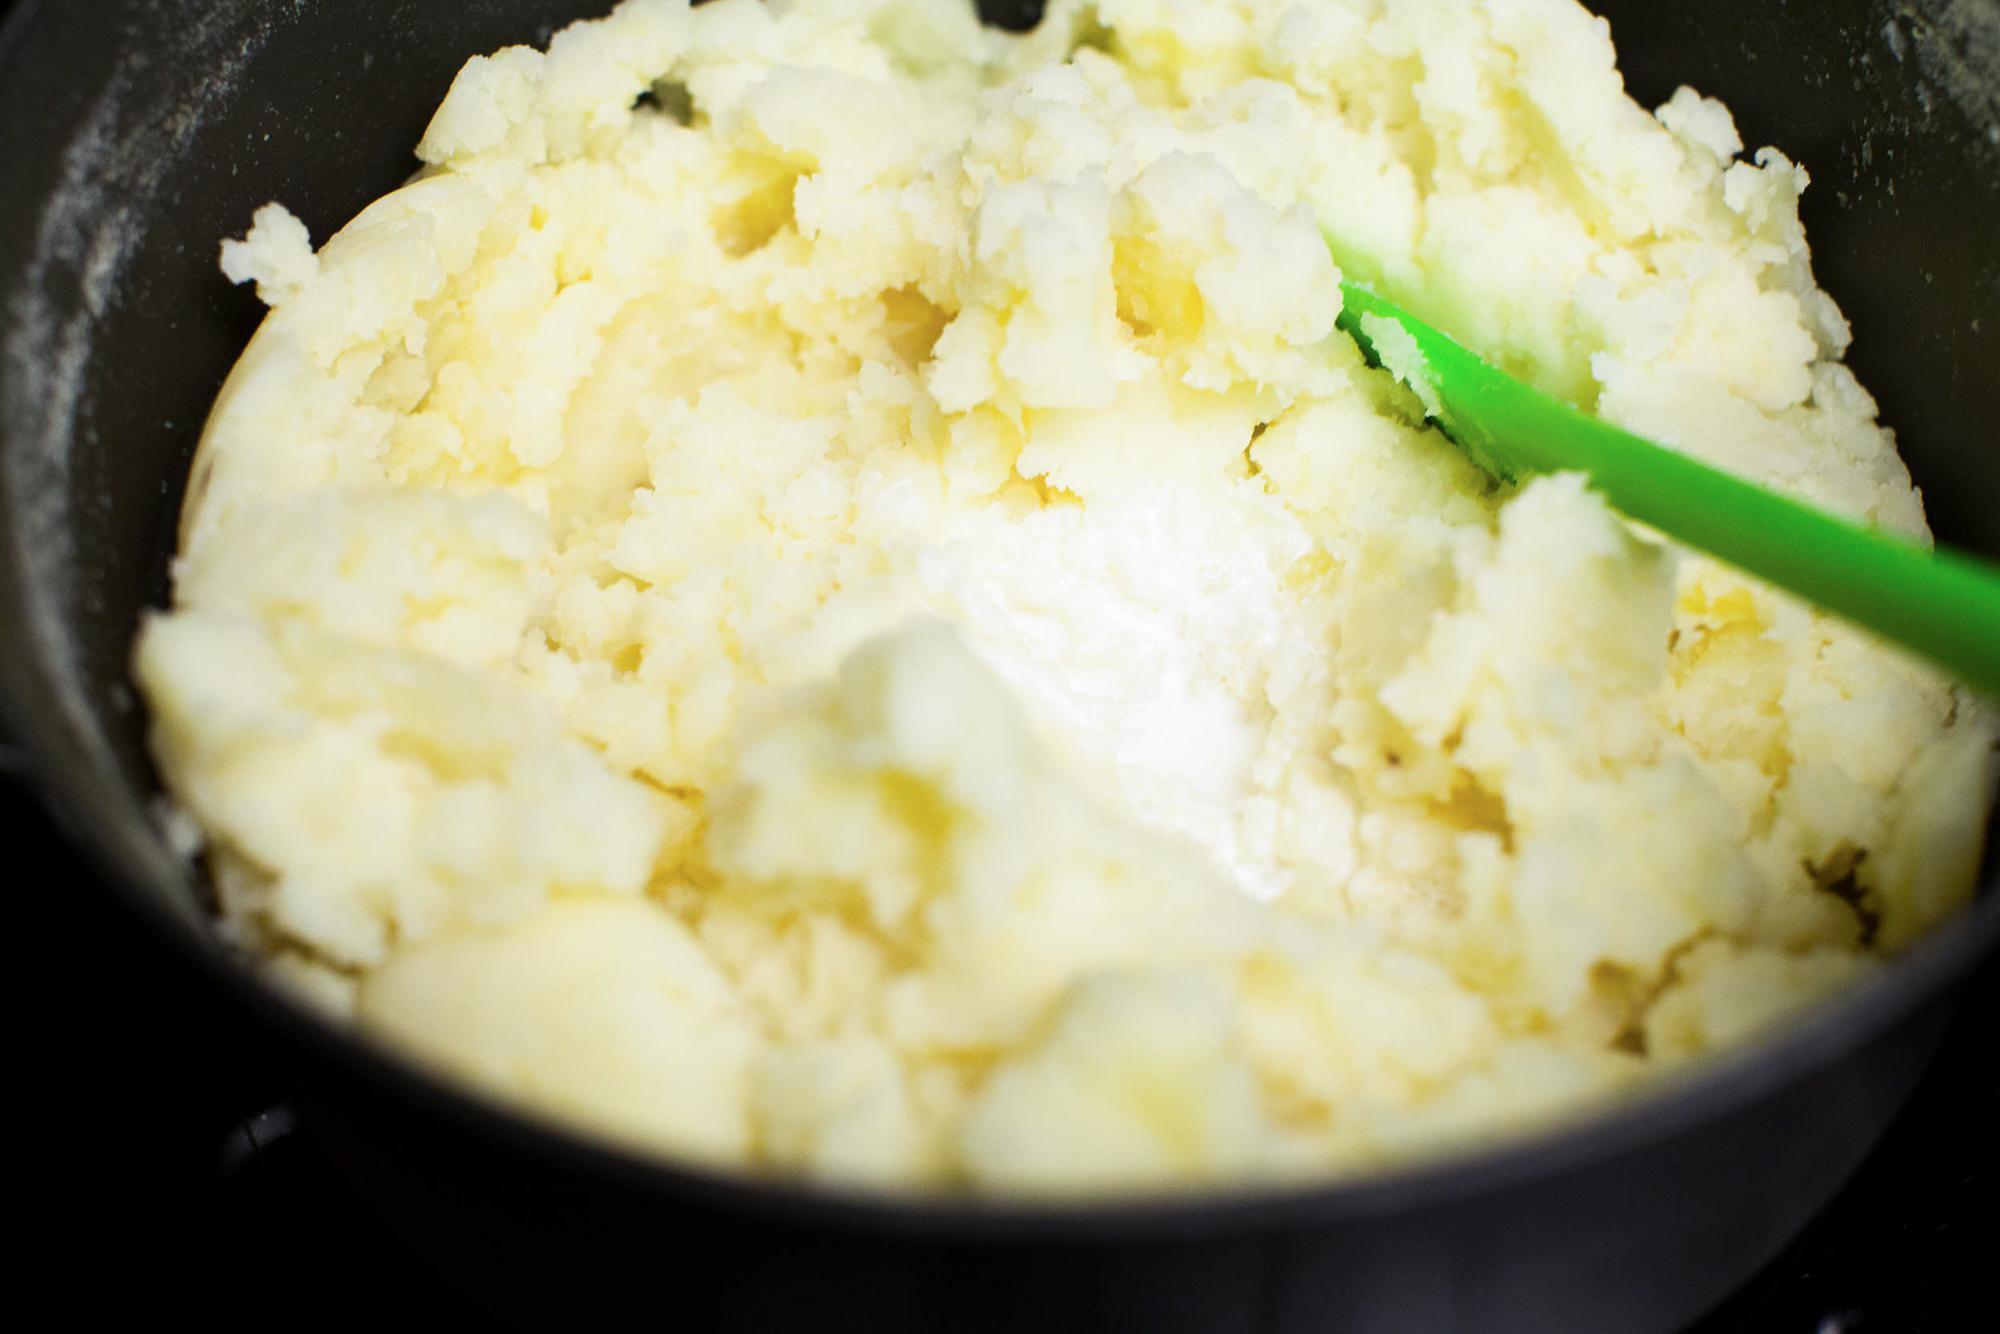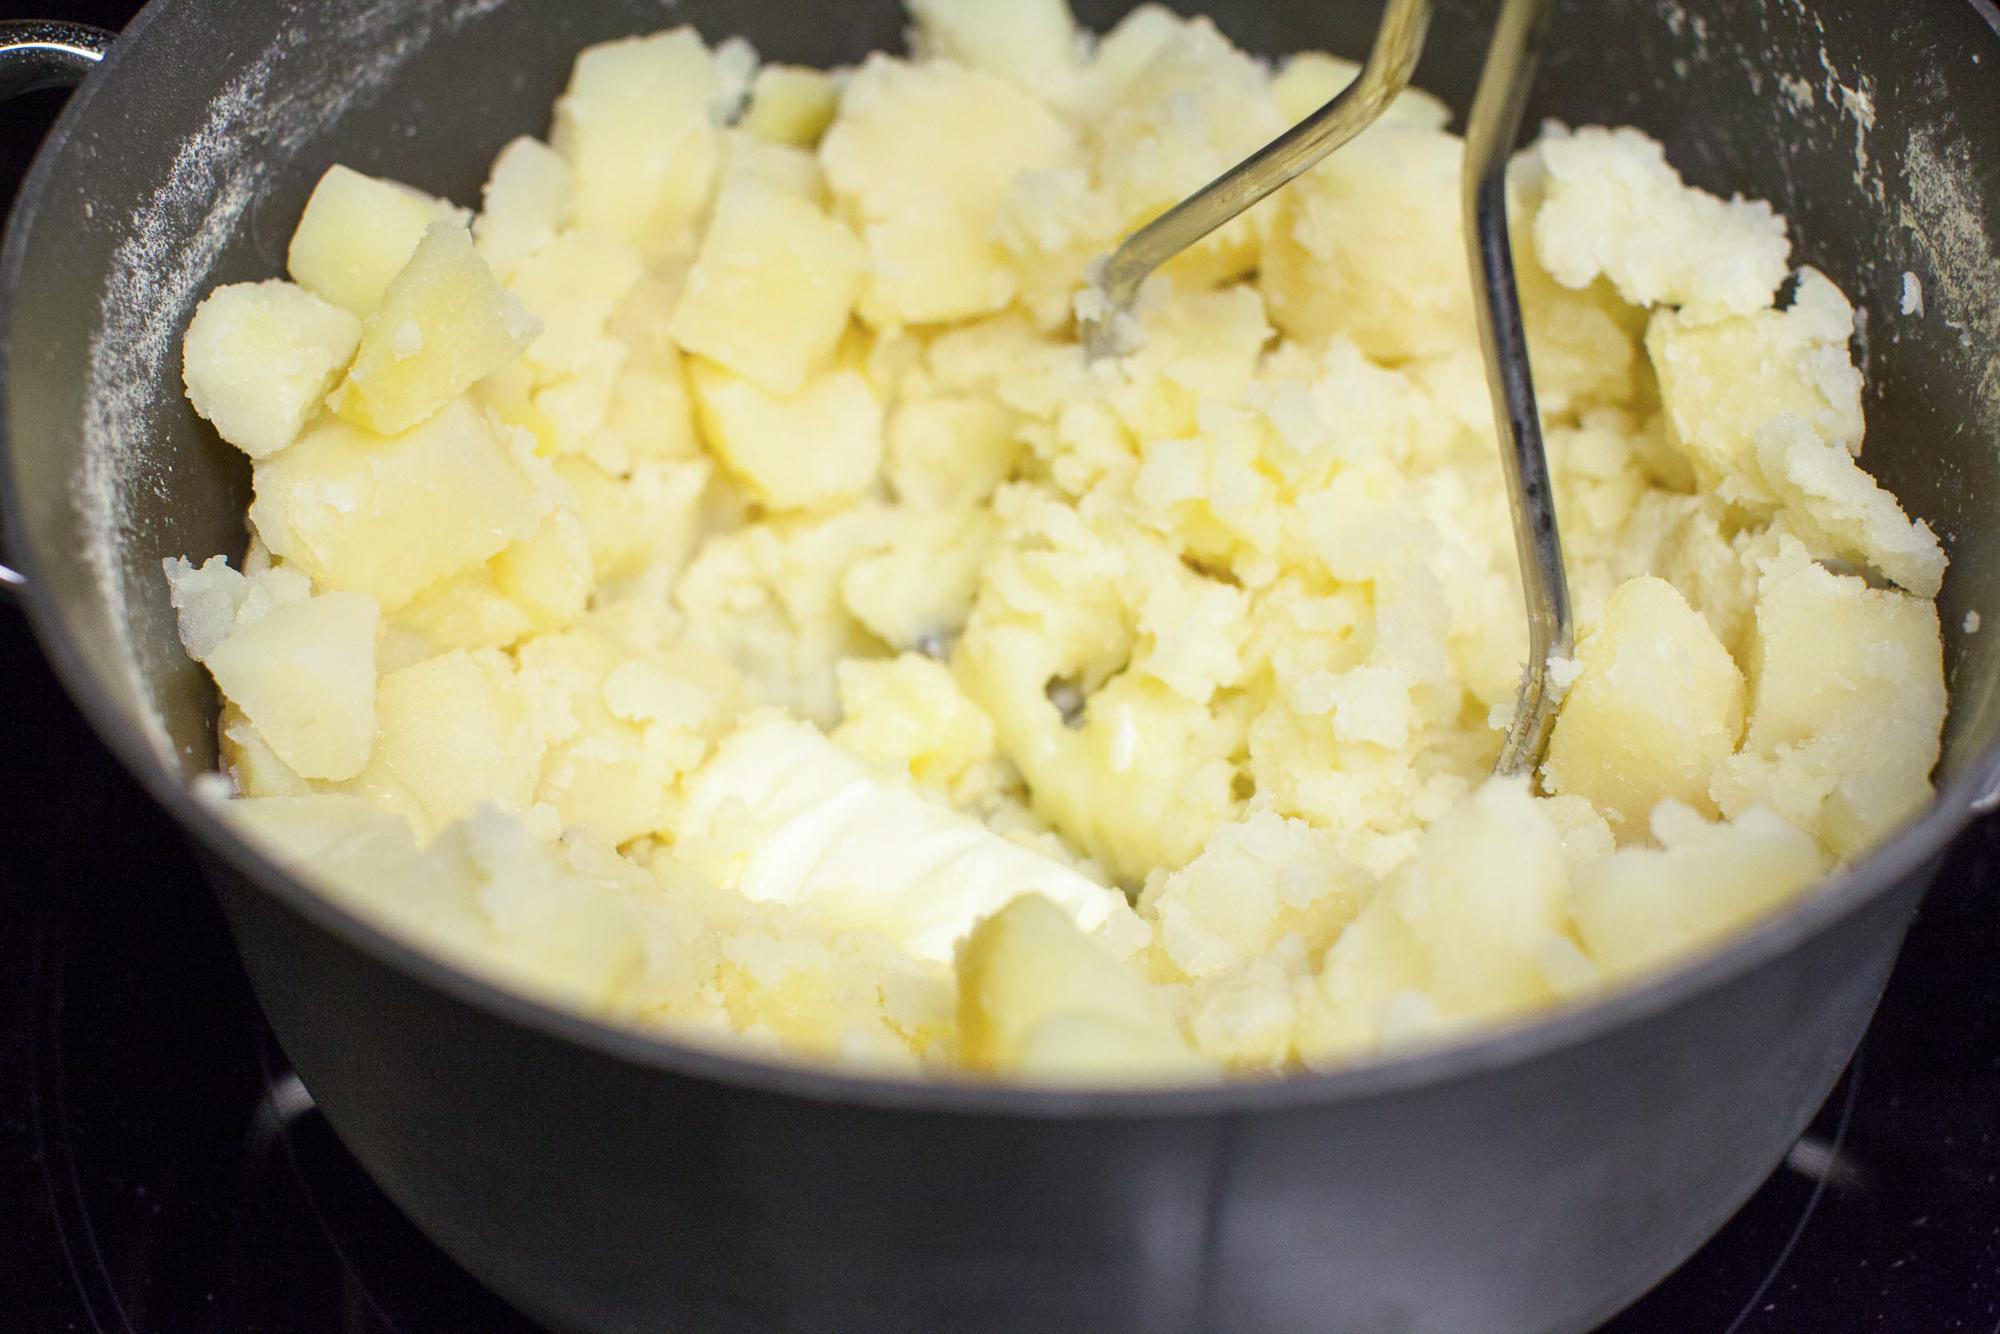The first image is the image on the left, the second image is the image on the right. Given the left and right images, does the statement "One image shows potatoes in a pot of water before boiling." hold true? Answer yes or no. No. 